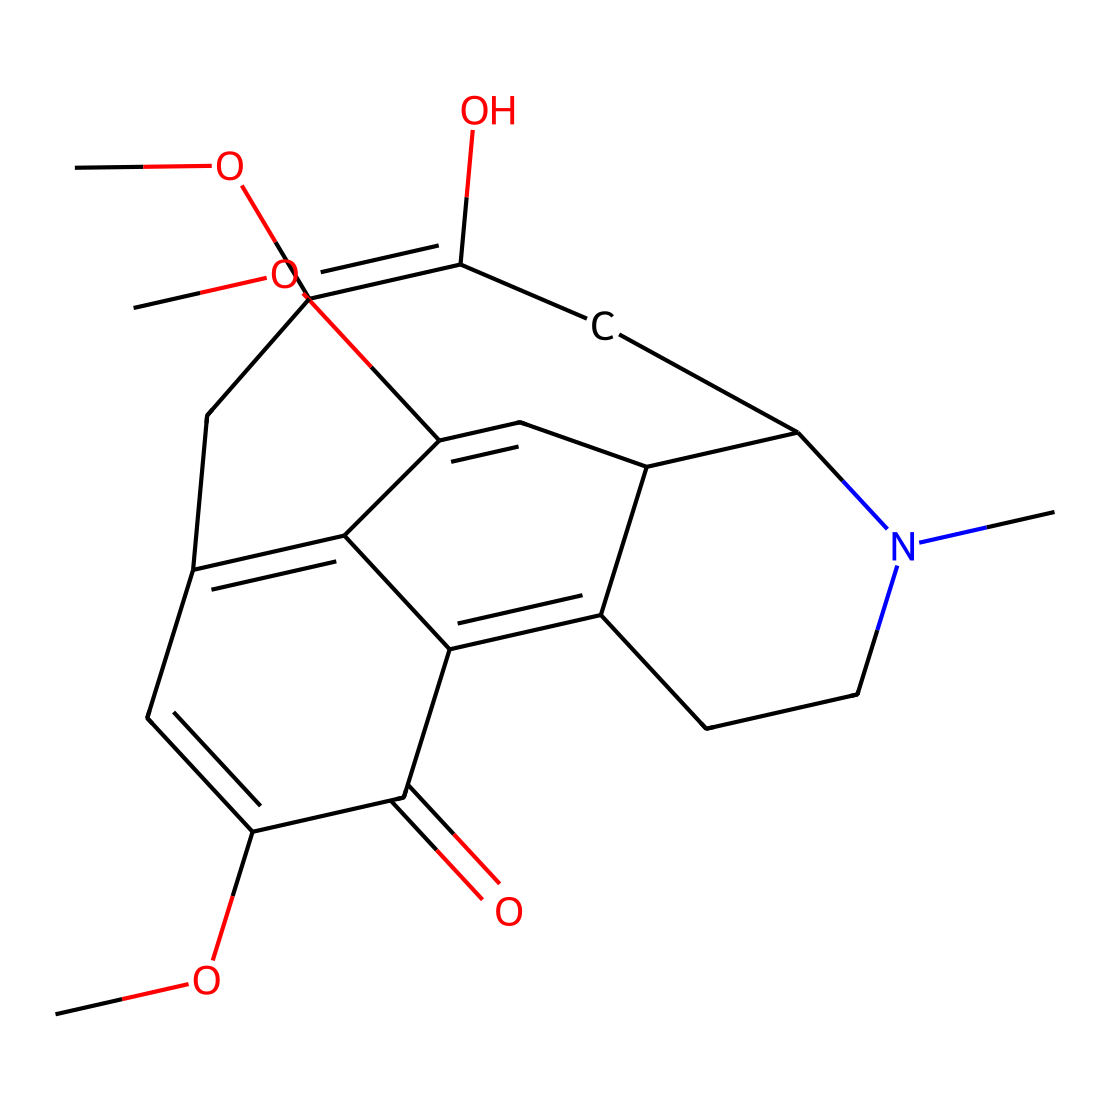What is the molecular formula of codeine? To determine the molecular formula, we can count the individual types of atoms from the SMILES representation. The breakdown yields C (carbon), H (hydrogen), N (nitrogen), and O (oxygen) counts. The final counts give us C18, H21, N1, O3.
Answer: C18H21N1O3 How many rings are present in this structure? Analyzing the SMILES notation reveals rings represented in the cyclic portions. The structure has multiple cyclic components which combine to form a total of four rings.
Answer: 4 What functional groups are present in codeine? By examining the structure, we can identify the presence of an ether group (due to the -O- between two carbon chains) and a hydroxyl group (-OH). These are specific functional groups present in codeine.
Answer: ether, hydroxyl How many double bonds are there? Counting the pi-bonds indicated by the presence of double bonds in the structure yields a total of five double bonds in the codeine molecule.
Answer: 5 What is the role of the nitrogen atom in codeine? The nitrogen atom typically contributes to the basicity and the narcotic effects of the compound. As it is part of the ring structure, it also influences the overall chemical properties including interaction with receptors.
Answer: basicity, narcotic Is codeine a cage compound? The presence of multiple interconnected rings in the structure fits the criteria for a cage compound, which is characterized by a closed, three-dimensional arrangement of atoms, thereby confirming codeine's classification.
Answer: yes 